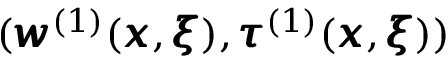Convert formula to latex. <formula><loc_0><loc_0><loc_500><loc_500>( { \pm b w } ^ { ( 1 ) } ( { \pm b x } , { \pm b \xi } ) , { \pm b \tau } ^ { ( 1 ) } ( { \pm b x } , { \pm b \xi } ) )</formula> 